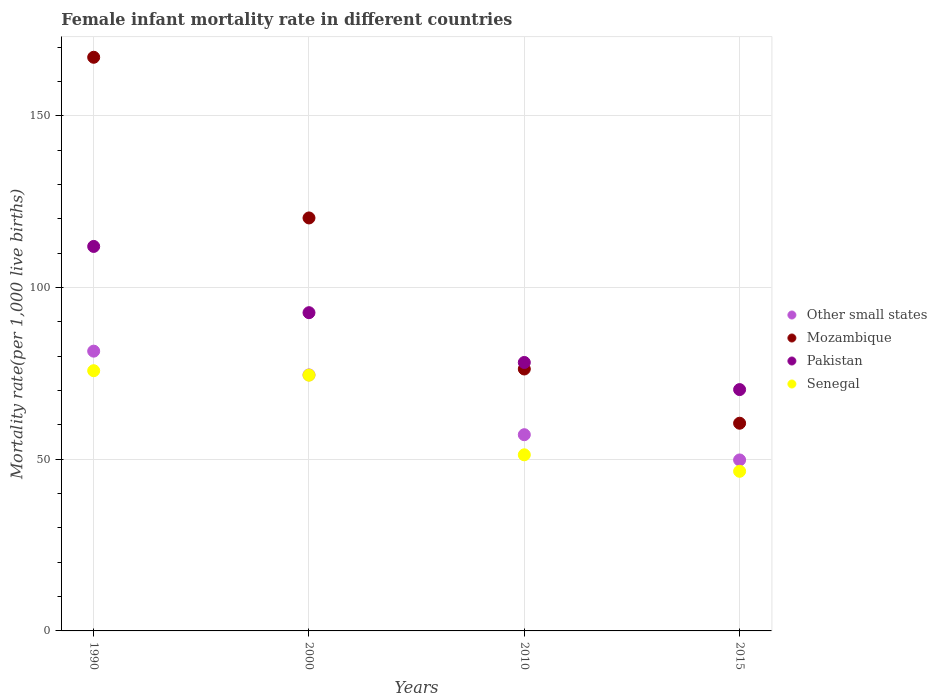Is the number of dotlines equal to the number of legend labels?
Your answer should be very brief. Yes. What is the female infant mortality rate in Mozambique in 2000?
Offer a very short reply. 120.3. Across all years, what is the maximum female infant mortality rate in Pakistan?
Give a very brief answer. 112. Across all years, what is the minimum female infant mortality rate in Senegal?
Give a very brief answer. 46.5. In which year was the female infant mortality rate in Other small states maximum?
Your answer should be compact. 1990. In which year was the female infant mortality rate in Pakistan minimum?
Keep it short and to the point. 2015. What is the total female infant mortality rate in Other small states in the graph?
Keep it short and to the point. 263.03. What is the difference between the female infant mortality rate in Senegal in 1990 and that in 2000?
Your answer should be very brief. 1.3. What is the difference between the female infant mortality rate in Pakistan in 2015 and the female infant mortality rate in Senegal in 2000?
Make the answer very short. -4.2. What is the average female infant mortality rate in Mozambique per year?
Your response must be concise. 106.05. In the year 2010, what is the difference between the female infant mortality rate in Senegal and female infant mortality rate in Other small states?
Provide a short and direct response. -5.86. What is the ratio of the female infant mortality rate in Other small states in 1990 to that in 2000?
Provide a short and direct response. 1.09. What is the difference between the highest and the second highest female infant mortality rate in Pakistan?
Your answer should be compact. 19.3. What is the difference between the highest and the lowest female infant mortality rate in Mozambique?
Provide a succinct answer. 106.6. Is the sum of the female infant mortality rate in Mozambique in 2010 and 2015 greater than the maximum female infant mortality rate in Pakistan across all years?
Your answer should be compact. Yes. Is it the case that in every year, the sum of the female infant mortality rate in Mozambique and female infant mortality rate in Senegal  is greater than the female infant mortality rate in Pakistan?
Make the answer very short. Yes. How many dotlines are there?
Make the answer very short. 4. What is the difference between two consecutive major ticks on the Y-axis?
Offer a terse response. 50. Does the graph contain grids?
Offer a terse response. Yes. How many legend labels are there?
Your answer should be very brief. 4. What is the title of the graph?
Offer a very short reply. Female infant mortality rate in different countries. What is the label or title of the Y-axis?
Make the answer very short. Mortality rate(per 1,0 live births). What is the Mortality rate(per 1,000 live births) of Other small states in 1990?
Your response must be concise. 81.5. What is the Mortality rate(per 1,000 live births) in Mozambique in 1990?
Offer a terse response. 167.1. What is the Mortality rate(per 1,000 live births) in Pakistan in 1990?
Make the answer very short. 112. What is the Mortality rate(per 1,000 live births) in Senegal in 1990?
Offer a very short reply. 75.8. What is the Mortality rate(per 1,000 live births) of Other small states in 2000?
Provide a succinct answer. 74.57. What is the Mortality rate(per 1,000 live births) in Mozambique in 2000?
Your answer should be compact. 120.3. What is the Mortality rate(per 1,000 live births) in Pakistan in 2000?
Offer a very short reply. 92.7. What is the Mortality rate(per 1,000 live births) in Senegal in 2000?
Give a very brief answer. 74.5. What is the Mortality rate(per 1,000 live births) in Other small states in 2010?
Provide a short and direct response. 57.16. What is the Mortality rate(per 1,000 live births) in Mozambique in 2010?
Provide a short and direct response. 76.3. What is the Mortality rate(per 1,000 live births) in Pakistan in 2010?
Provide a succinct answer. 78.2. What is the Mortality rate(per 1,000 live births) of Senegal in 2010?
Your answer should be compact. 51.3. What is the Mortality rate(per 1,000 live births) of Other small states in 2015?
Your answer should be very brief. 49.81. What is the Mortality rate(per 1,000 live births) of Mozambique in 2015?
Your answer should be compact. 60.5. What is the Mortality rate(per 1,000 live births) in Pakistan in 2015?
Provide a succinct answer. 70.3. What is the Mortality rate(per 1,000 live births) of Senegal in 2015?
Your response must be concise. 46.5. Across all years, what is the maximum Mortality rate(per 1,000 live births) of Other small states?
Your answer should be very brief. 81.5. Across all years, what is the maximum Mortality rate(per 1,000 live births) in Mozambique?
Your answer should be very brief. 167.1. Across all years, what is the maximum Mortality rate(per 1,000 live births) of Pakistan?
Your answer should be very brief. 112. Across all years, what is the maximum Mortality rate(per 1,000 live births) of Senegal?
Give a very brief answer. 75.8. Across all years, what is the minimum Mortality rate(per 1,000 live births) in Other small states?
Your answer should be compact. 49.81. Across all years, what is the minimum Mortality rate(per 1,000 live births) of Mozambique?
Provide a succinct answer. 60.5. Across all years, what is the minimum Mortality rate(per 1,000 live births) of Pakistan?
Offer a very short reply. 70.3. Across all years, what is the minimum Mortality rate(per 1,000 live births) of Senegal?
Keep it short and to the point. 46.5. What is the total Mortality rate(per 1,000 live births) of Other small states in the graph?
Your answer should be very brief. 263.03. What is the total Mortality rate(per 1,000 live births) in Mozambique in the graph?
Your answer should be very brief. 424.2. What is the total Mortality rate(per 1,000 live births) of Pakistan in the graph?
Offer a terse response. 353.2. What is the total Mortality rate(per 1,000 live births) in Senegal in the graph?
Offer a terse response. 248.1. What is the difference between the Mortality rate(per 1,000 live births) of Other small states in 1990 and that in 2000?
Your answer should be compact. 6.93. What is the difference between the Mortality rate(per 1,000 live births) in Mozambique in 1990 and that in 2000?
Offer a very short reply. 46.8. What is the difference between the Mortality rate(per 1,000 live births) of Pakistan in 1990 and that in 2000?
Your answer should be very brief. 19.3. What is the difference between the Mortality rate(per 1,000 live births) in Other small states in 1990 and that in 2010?
Your response must be concise. 24.34. What is the difference between the Mortality rate(per 1,000 live births) in Mozambique in 1990 and that in 2010?
Offer a very short reply. 90.8. What is the difference between the Mortality rate(per 1,000 live births) of Pakistan in 1990 and that in 2010?
Offer a terse response. 33.8. What is the difference between the Mortality rate(per 1,000 live births) in Senegal in 1990 and that in 2010?
Your answer should be compact. 24.5. What is the difference between the Mortality rate(per 1,000 live births) in Other small states in 1990 and that in 2015?
Make the answer very short. 31.69. What is the difference between the Mortality rate(per 1,000 live births) of Mozambique in 1990 and that in 2015?
Your response must be concise. 106.6. What is the difference between the Mortality rate(per 1,000 live births) in Pakistan in 1990 and that in 2015?
Give a very brief answer. 41.7. What is the difference between the Mortality rate(per 1,000 live births) in Senegal in 1990 and that in 2015?
Your response must be concise. 29.3. What is the difference between the Mortality rate(per 1,000 live births) of Other small states in 2000 and that in 2010?
Give a very brief answer. 17.41. What is the difference between the Mortality rate(per 1,000 live births) of Pakistan in 2000 and that in 2010?
Provide a short and direct response. 14.5. What is the difference between the Mortality rate(per 1,000 live births) in Senegal in 2000 and that in 2010?
Ensure brevity in your answer.  23.2. What is the difference between the Mortality rate(per 1,000 live births) in Other small states in 2000 and that in 2015?
Offer a very short reply. 24.76. What is the difference between the Mortality rate(per 1,000 live births) in Mozambique in 2000 and that in 2015?
Offer a terse response. 59.8. What is the difference between the Mortality rate(per 1,000 live births) of Pakistan in 2000 and that in 2015?
Your answer should be very brief. 22.4. What is the difference between the Mortality rate(per 1,000 live births) in Senegal in 2000 and that in 2015?
Provide a succinct answer. 28. What is the difference between the Mortality rate(per 1,000 live births) of Other small states in 2010 and that in 2015?
Give a very brief answer. 7.35. What is the difference between the Mortality rate(per 1,000 live births) in Senegal in 2010 and that in 2015?
Your answer should be compact. 4.8. What is the difference between the Mortality rate(per 1,000 live births) of Other small states in 1990 and the Mortality rate(per 1,000 live births) of Mozambique in 2000?
Make the answer very short. -38.8. What is the difference between the Mortality rate(per 1,000 live births) in Other small states in 1990 and the Mortality rate(per 1,000 live births) in Pakistan in 2000?
Your answer should be compact. -11.2. What is the difference between the Mortality rate(per 1,000 live births) in Other small states in 1990 and the Mortality rate(per 1,000 live births) in Senegal in 2000?
Make the answer very short. 7. What is the difference between the Mortality rate(per 1,000 live births) of Mozambique in 1990 and the Mortality rate(per 1,000 live births) of Pakistan in 2000?
Make the answer very short. 74.4. What is the difference between the Mortality rate(per 1,000 live births) in Mozambique in 1990 and the Mortality rate(per 1,000 live births) in Senegal in 2000?
Your answer should be very brief. 92.6. What is the difference between the Mortality rate(per 1,000 live births) of Pakistan in 1990 and the Mortality rate(per 1,000 live births) of Senegal in 2000?
Provide a succinct answer. 37.5. What is the difference between the Mortality rate(per 1,000 live births) of Other small states in 1990 and the Mortality rate(per 1,000 live births) of Mozambique in 2010?
Keep it short and to the point. 5.2. What is the difference between the Mortality rate(per 1,000 live births) in Other small states in 1990 and the Mortality rate(per 1,000 live births) in Pakistan in 2010?
Ensure brevity in your answer.  3.3. What is the difference between the Mortality rate(per 1,000 live births) in Other small states in 1990 and the Mortality rate(per 1,000 live births) in Senegal in 2010?
Provide a succinct answer. 30.2. What is the difference between the Mortality rate(per 1,000 live births) in Mozambique in 1990 and the Mortality rate(per 1,000 live births) in Pakistan in 2010?
Your answer should be compact. 88.9. What is the difference between the Mortality rate(per 1,000 live births) in Mozambique in 1990 and the Mortality rate(per 1,000 live births) in Senegal in 2010?
Provide a succinct answer. 115.8. What is the difference between the Mortality rate(per 1,000 live births) in Pakistan in 1990 and the Mortality rate(per 1,000 live births) in Senegal in 2010?
Give a very brief answer. 60.7. What is the difference between the Mortality rate(per 1,000 live births) in Other small states in 1990 and the Mortality rate(per 1,000 live births) in Mozambique in 2015?
Provide a short and direct response. 21. What is the difference between the Mortality rate(per 1,000 live births) of Other small states in 1990 and the Mortality rate(per 1,000 live births) of Pakistan in 2015?
Provide a succinct answer. 11.2. What is the difference between the Mortality rate(per 1,000 live births) of Other small states in 1990 and the Mortality rate(per 1,000 live births) of Senegal in 2015?
Keep it short and to the point. 35. What is the difference between the Mortality rate(per 1,000 live births) of Mozambique in 1990 and the Mortality rate(per 1,000 live births) of Pakistan in 2015?
Provide a succinct answer. 96.8. What is the difference between the Mortality rate(per 1,000 live births) of Mozambique in 1990 and the Mortality rate(per 1,000 live births) of Senegal in 2015?
Your response must be concise. 120.6. What is the difference between the Mortality rate(per 1,000 live births) of Pakistan in 1990 and the Mortality rate(per 1,000 live births) of Senegal in 2015?
Offer a terse response. 65.5. What is the difference between the Mortality rate(per 1,000 live births) of Other small states in 2000 and the Mortality rate(per 1,000 live births) of Mozambique in 2010?
Make the answer very short. -1.73. What is the difference between the Mortality rate(per 1,000 live births) in Other small states in 2000 and the Mortality rate(per 1,000 live births) in Pakistan in 2010?
Your answer should be very brief. -3.63. What is the difference between the Mortality rate(per 1,000 live births) of Other small states in 2000 and the Mortality rate(per 1,000 live births) of Senegal in 2010?
Make the answer very short. 23.27. What is the difference between the Mortality rate(per 1,000 live births) of Mozambique in 2000 and the Mortality rate(per 1,000 live births) of Pakistan in 2010?
Provide a short and direct response. 42.1. What is the difference between the Mortality rate(per 1,000 live births) in Pakistan in 2000 and the Mortality rate(per 1,000 live births) in Senegal in 2010?
Provide a short and direct response. 41.4. What is the difference between the Mortality rate(per 1,000 live births) in Other small states in 2000 and the Mortality rate(per 1,000 live births) in Mozambique in 2015?
Ensure brevity in your answer.  14.07. What is the difference between the Mortality rate(per 1,000 live births) of Other small states in 2000 and the Mortality rate(per 1,000 live births) of Pakistan in 2015?
Your response must be concise. 4.27. What is the difference between the Mortality rate(per 1,000 live births) of Other small states in 2000 and the Mortality rate(per 1,000 live births) of Senegal in 2015?
Provide a short and direct response. 28.07. What is the difference between the Mortality rate(per 1,000 live births) in Mozambique in 2000 and the Mortality rate(per 1,000 live births) in Pakistan in 2015?
Your response must be concise. 50. What is the difference between the Mortality rate(per 1,000 live births) in Mozambique in 2000 and the Mortality rate(per 1,000 live births) in Senegal in 2015?
Provide a short and direct response. 73.8. What is the difference between the Mortality rate(per 1,000 live births) of Pakistan in 2000 and the Mortality rate(per 1,000 live births) of Senegal in 2015?
Offer a terse response. 46.2. What is the difference between the Mortality rate(per 1,000 live births) in Other small states in 2010 and the Mortality rate(per 1,000 live births) in Mozambique in 2015?
Ensure brevity in your answer.  -3.34. What is the difference between the Mortality rate(per 1,000 live births) in Other small states in 2010 and the Mortality rate(per 1,000 live births) in Pakistan in 2015?
Keep it short and to the point. -13.14. What is the difference between the Mortality rate(per 1,000 live births) in Other small states in 2010 and the Mortality rate(per 1,000 live births) in Senegal in 2015?
Offer a terse response. 10.66. What is the difference between the Mortality rate(per 1,000 live births) of Mozambique in 2010 and the Mortality rate(per 1,000 live births) of Senegal in 2015?
Ensure brevity in your answer.  29.8. What is the difference between the Mortality rate(per 1,000 live births) of Pakistan in 2010 and the Mortality rate(per 1,000 live births) of Senegal in 2015?
Make the answer very short. 31.7. What is the average Mortality rate(per 1,000 live births) of Other small states per year?
Make the answer very short. 65.76. What is the average Mortality rate(per 1,000 live births) of Mozambique per year?
Your answer should be compact. 106.05. What is the average Mortality rate(per 1,000 live births) of Pakistan per year?
Provide a short and direct response. 88.3. What is the average Mortality rate(per 1,000 live births) of Senegal per year?
Keep it short and to the point. 62.02. In the year 1990, what is the difference between the Mortality rate(per 1,000 live births) in Other small states and Mortality rate(per 1,000 live births) in Mozambique?
Make the answer very short. -85.6. In the year 1990, what is the difference between the Mortality rate(per 1,000 live births) in Other small states and Mortality rate(per 1,000 live births) in Pakistan?
Keep it short and to the point. -30.5. In the year 1990, what is the difference between the Mortality rate(per 1,000 live births) in Other small states and Mortality rate(per 1,000 live births) in Senegal?
Your answer should be very brief. 5.7. In the year 1990, what is the difference between the Mortality rate(per 1,000 live births) of Mozambique and Mortality rate(per 1,000 live births) of Pakistan?
Offer a very short reply. 55.1. In the year 1990, what is the difference between the Mortality rate(per 1,000 live births) of Mozambique and Mortality rate(per 1,000 live births) of Senegal?
Provide a succinct answer. 91.3. In the year 1990, what is the difference between the Mortality rate(per 1,000 live births) in Pakistan and Mortality rate(per 1,000 live births) in Senegal?
Provide a short and direct response. 36.2. In the year 2000, what is the difference between the Mortality rate(per 1,000 live births) of Other small states and Mortality rate(per 1,000 live births) of Mozambique?
Your response must be concise. -45.73. In the year 2000, what is the difference between the Mortality rate(per 1,000 live births) in Other small states and Mortality rate(per 1,000 live births) in Pakistan?
Your answer should be very brief. -18.13. In the year 2000, what is the difference between the Mortality rate(per 1,000 live births) in Other small states and Mortality rate(per 1,000 live births) in Senegal?
Give a very brief answer. 0.07. In the year 2000, what is the difference between the Mortality rate(per 1,000 live births) of Mozambique and Mortality rate(per 1,000 live births) of Pakistan?
Your answer should be very brief. 27.6. In the year 2000, what is the difference between the Mortality rate(per 1,000 live births) in Mozambique and Mortality rate(per 1,000 live births) in Senegal?
Your answer should be very brief. 45.8. In the year 2010, what is the difference between the Mortality rate(per 1,000 live births) in Other small states and Mortality rate(per 1,000 live births) in Mozambique?
Ensure brevity in your answer.  -19.14. In the year 2010, what is the difference between the Mortality rate(per 1,000 live births) of Other small states and Mortality rate(per 1,000 live births) of Pakistan?
Offer a terse response. -21.04. In the year 2010, what is the difference between the Mortality rate(per 1,000 live births) of Other small states and Mortality rate(per 1,000 live births) of Senegal?
Offer a terse response. 5.86. In the year 2010, what is the difference between the Mortality rate(per 1,000 live births) of Mozambique and Mortality rate(per 1,000 live births) of Pakistan?
Provide a short and direct response. -1.9. In the year 2010, what is the difference between the Mortality rate(per 1,000 live births) of Mozambique and Mortality rate(per 1,000 live births) of Senegal?
Your answer should be very brief. 25. In the year 2010, what is the difference between the Mortality rate(per 1,000 live births) of Pakistan and Mortality rate(per 1,000 live births) of Senegal?
Ensure brevity in your answer.  26.9. In the year 2015, what is the difference between the Mortality rate(per 1,000 live births) of Other small states and Mortality rate(per 1,000 live births) of Mozambique?
Your response must be concise. -10.69. In the year 2015, what is the difference between the Mortality rate(per 1,000 live births) of Other small states and Mortality rate(per 1,000 live births) of Pakistan?
Provide a short and direct response. -20.49. In the year 2015, what is the difference between the Mortality rate(per 1,000 live births) in Other small states and Mortality rate(per 1,000 live births) in Senegal?
Offer a very short reply. 3.31. In the year 2015, what is the difference between the Mortality rate(per 1,000 live births) of Mozambique and Mortality rate(per 1,000 live births) of Senegal?
Provide a short and direct response. 14. In the year 2015, what is the difference between the Mortality rate(per 1,000 live births) in Pakistan and Mortality rate(per 1,000 live births) in Senegal?
Keep it short and to the point. 23.8. What is the ratio of the Mortality rate(per 1,000 live births) of Other small states in 1990 to that in 2000?
Your response must be concise. 1.09. What is the ratio of the Mortality rate(per 1,000 live births) of Mozambique in 1990 to that in 2000?
Provide a succinct answer. 1.39. What is the ratio of the Mortality rate(per 1,000 live births) of Pakistan in 1990 to that in 2000?
Make the answer very short. 1.21. What is the ratio of the Mortality rate(per 1,000 live births) of Senegal in 1990 to that in 2000?
Keep it short and to the point. 1.02. What is the ratio of the Mortality rate(per 1,000 live births) in Other small states in 1990 to that in 2010?
Offer a terse response. 1.43. What is the ratio of the Mortality rate(per 1,000 live births) in Mozambique in 1990 to that in 2010?
Your answer should be very brief. 2.19. What is the ratio of the Mortality rate(per 1,000 live births) of Pakistan in 1990 to that in 2010?
Your response must be concise. 1.43. What is the ratio of the Mortality rate(per 1,000 live births) in Senegal in 1990 to that in 2010?
Give a very brief answer. 1.48. What is the ratio of the Mortality rate(per 1,000 live births) in Other small states in 1990 to that in 2015?
Offer a terse response. 1.64. What is the ratio of the Mortality rate(per 1,000 live births) of Mozambique in 1990 to that in 2015?
Your answer should be compact. 2.76. What is the ratio of the Mortality rate(per 1,000 live births) of Pakistan in 1990 to that in 2015?
Ensure brevity in your answer.  1.59. What is the ratio of the Mortality rate(per 1,000 live births) in Senegal in 1990 to that in 2015?
Provide a short and direct response. 1.63. What is the ratio of the Mortality rate(per 1,000 live births) in Other small states in 2000 to that in 2010?
Ensure brevity in your answer.  1.3. What is the ratio of the Mortality rate(per 1,000 live births) of Mozambique in 2000 to that in 2010?
Make the answer very short. 1.58. What is the ratio of the Mortality rate(per 1,000 live births) in Pakistan in 2000 to that in 2010?
Provide a succinct answer. 1.19. What is the ratio of the Mortality rate(per 1,000 live births) in Senegal in 2000 to that in 2010?
Ensure brevity in your answer.  1.45. What is the ratio of the Mortality rate(per 1,000 live births) of Other small states in 2000 to that in 2015?
Make the answer very short. 1.5. What is the ratio of the Mortality rate(per 1,000 live births) of Mozambique in 2000 to that in 2015?
Provide a succinct answer. 1.99. What is the ratio of the Mortality rate(per 1,000 live births) of Pakistan in 2000 to that in 2015?
Ensure brevity in your answer.  1.32. What is the ratio of the Mortality rate(per 1,000 live births) in Senegal in 2000 to that in 2015?
Keep it short and to the point. 1.6. What is the ratio of the Mortality rate(per 1,000 live births) of Other small states in 2010 to that in 2015?
Provide a succinct answer. 1.15. What is the ratio of the Mortality rate(per 1,000 live births) in Mozambique in 2010 to that in 2015?
Your answer should be very brief. 1.26. What is the ratio of the Mortality rate(per 1,000 live births) in Pakistan in 2010 to that in 2015?
Your response must be concise. 1.11. What is the ratio of the Mortality rate(per 1,000 live births) of Senegal in 2010 to that in 2015?
Offer a terse response. 1.1. What is the difference between the highest and the second highest Mortality rate(per 1,000 live births) in Other small states?
Your answer should be compact. 6.93. What is the difference between the highest and the second highest Mortality rate(per 1,000 live births) of Mozambique?
Keep it short and to the point. 46.8. What is the difference between the highest and the second highest Mortality rate(per 1,000 live births) in Pakistan?
Offer a very short reply. 19.3. What is the difference between the highest and the second highest Mortality rate(per 1,000 live births) of Senegal?
Your answer should be very brief. 1.3. What is the difference between the highest and the lowest Mortality rate(per 1,000 live births) in Other small states?
Make the answer very short. 31.69. What is the difference between the highest and the lowest Mortality rate(per 1,000 live births) in Mozambique?
Your response must be concise. 106.6. What is the difference between the highest and the lowest Mortality rate(per 1,000 live births) of Pakistan?
Keep it short and to the point. 41.7. What is the difference between the highest and the lowest Mortality rate(per 1,000 live births) of Senegal?
Give a very brief answer. 29.3. 